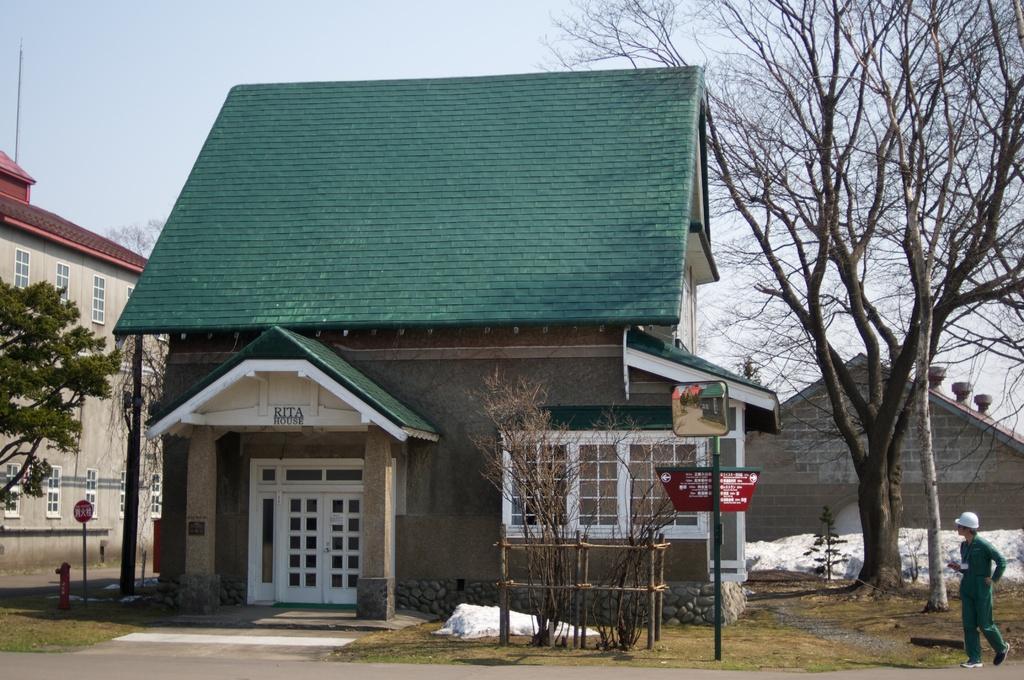In one or two sentences, can you explain what this image depicts? In this image I can see a buildings,white door and windows. I can see trees,pole,sign boards,fire-hydrant and snow. The sky is in white and blue color. I can see a person standing. 